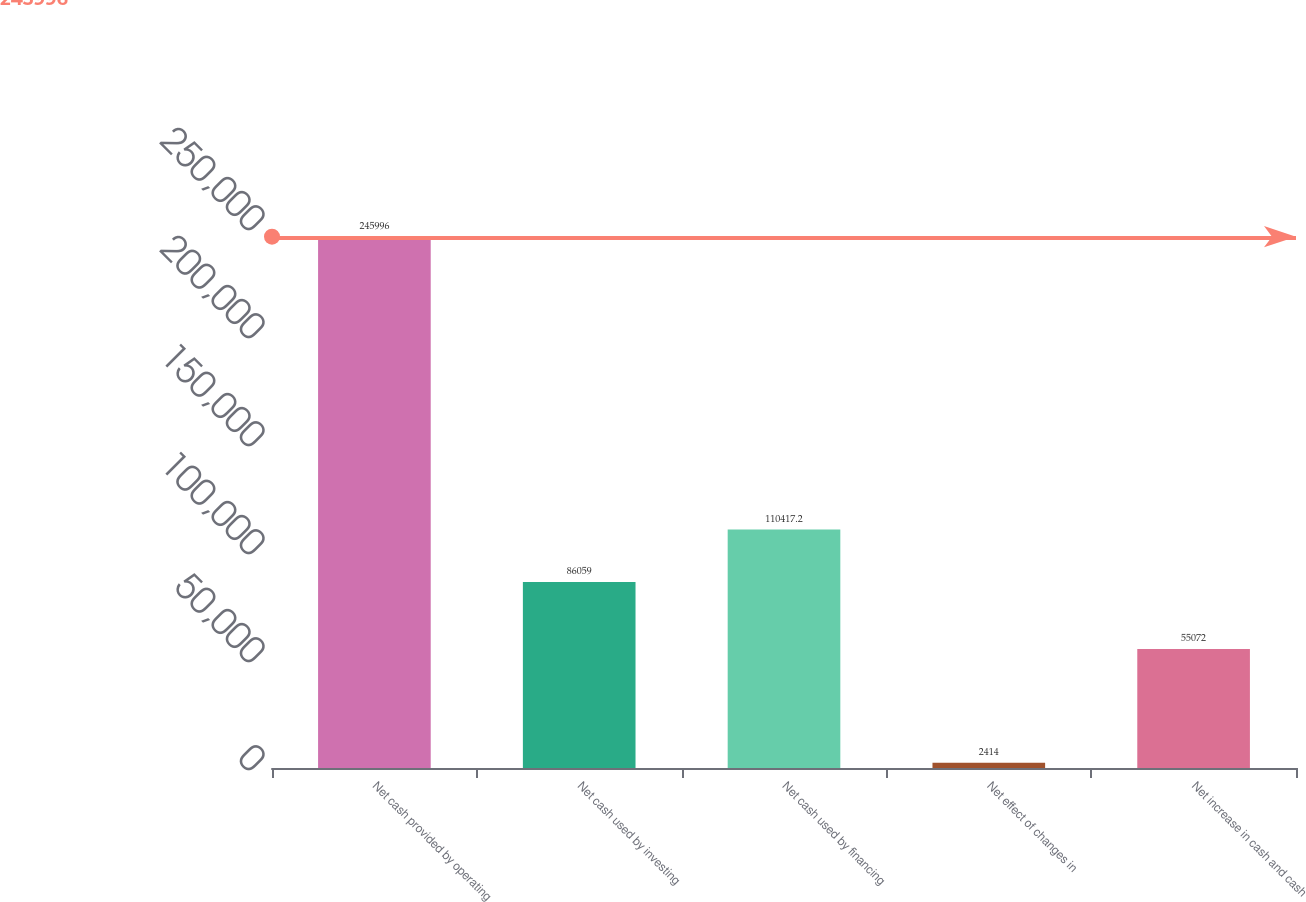<chart> <loc_0><loc_0><loc_500><loc_500><bar_chart><fcel>Net cash provided by operating<fcel>Net cash used by investing<fcel>Net cash used by financing<fcel>Net effect of changes in<fcel>Net increase in cash and cash<nl><fcel>245996<fcel>86059<fcel>110417<fcel>2414<fcel>55072<nl></chart> 